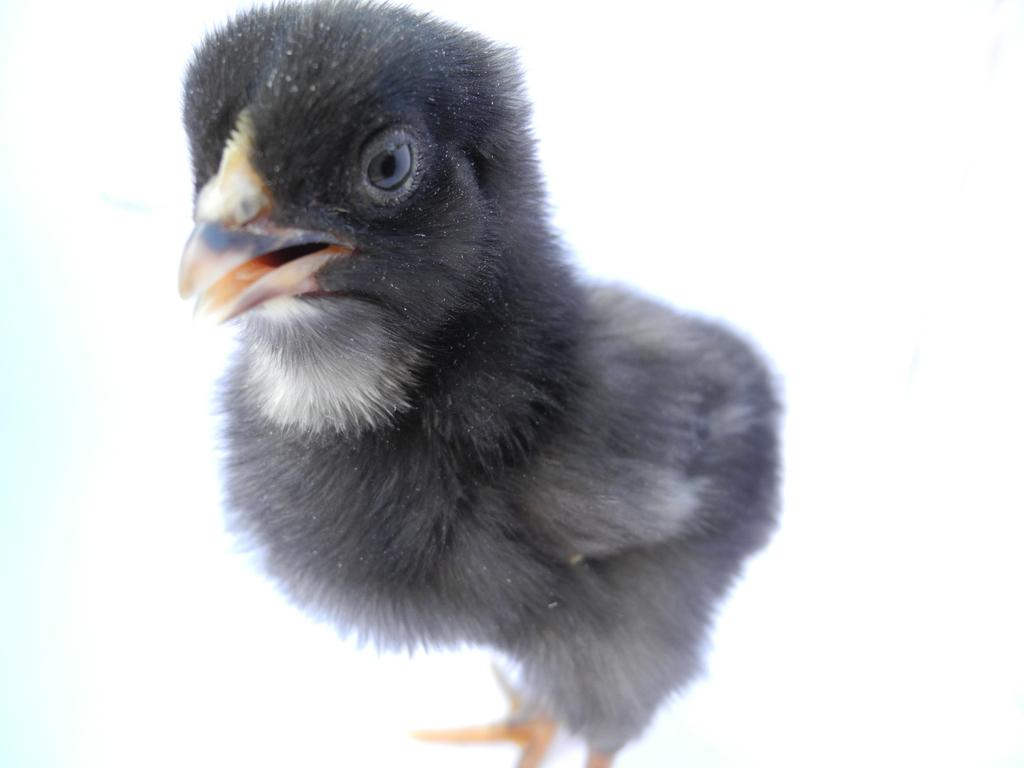What type of animal is in the image? There is a black color chicken bird in the image. What color is the background of the image? The background of the image is white. What type of soap is being used to clean the cemetery in the image? A: There is no soap or cemetery present in the image; it features a black color chicken bird against a white background. 